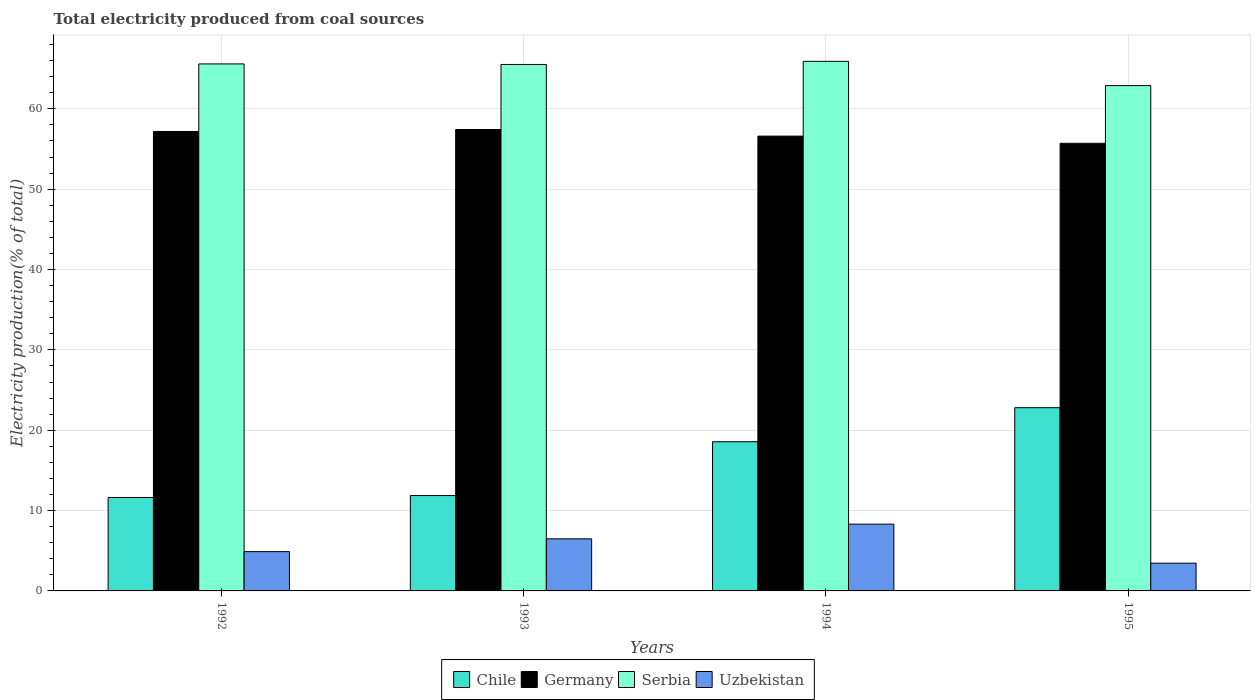How many different coloured bars are there?
Make the answer very short. 4. How many groups of bars are there?
Offer a terse response. 4. Are the number of bars per tick equal to the number of legend labels?
Make the answer very short. Yes. In how many cases, is the number of bars for a given year not equal to the number of legend labels?
Keep it short and to the point. 0. What is the total electricity produced in Serbia in 1995?
Provide a short and direct response. 62.89. Across all years, what is the maximum total electricity produced in Germany?
Ensure brevity in your answer.  57.43. Across all years, what is the minimum total electricity produced in Serbia?
Your answer should be compact. 62.89. In which year was the total electricity produced in Serbia maximum?
Your answer should be compact. 1994. What is the total total electricity produced in Chile in the graph?
Provide a succinct answer. 64.87. What is the difference between the total electricity produced in Chile in 1993 and that in 1995?
Your answer should be compact. -10.93. What is the difference between the total electricity produced in Germany in 1992 and the total electricity produced in Serbia in 1993?
Offer a terse response. -8.34. What is the average total electricity produced in Germany per year?
Your answer should be compact. 56.73. In the year 1992, what is the difference between the total electricity produced in Serbia and total electricity produced in Uzbekistan?
Provide a succinct answer. 60.7. In how many years, is the total electricity produced in Serbia greater than 34 %?
Ensure brevity in your answer.  4. What is the ratio of the total electricity produced in Germany in 1992 to that in 1995?
Ensure brevity in your answer.  1.03. Is the total electricity produced in Uzbekistan in 1994 less than that in 1995?
Make the answer very short. No. What is the difference between the highest and the second highest total electricity produced in Germany?
Provide a short and direct response. 0.24. What is the difference between the highest and the lowest total electricity produced in Serbia?
Make the answer very short. 3.02. In how many years, is the total electricity produced in Chile greater than the average total electricity produced in Chile taken over all years?
Give a very brief answer. 2. Is it the case that in every year, the sum of the total electricity produced in Uzbekistan and total electricity produced in Germany is greater than the sum of total electricity produced in Chile and total electricity produced in Serbia?
Offer a terse response. Yes. What does the 2nd bar from the left in 1994 represents?
Provide a short and direct response. Germany. Is it the case that in every year, the sum of the total electricity produced in Uzbekistan and total electricity produced in Germany is greater than the total electricity produced in Serbia?
Keep it short and to the point. No. How many bars are there?
Offer a terse response. 16. How many years are there in the graph?
Ensure brevity in your answer.  4. Does the graph contain any zero values?
Give a very brief answer. No. Where does the legend appear in the graph?
Ensure brevity in your answer.  Bottom center. What is the title of the graph?
Make the answer very short. Total electricity produced from coal sources. What is the label or title of the Y-axis?
Your answer should be compact. Electricity production(% of total). What is the Electricity production(% of total) of Chile in 1992?
Provide a short and direct response. 11.63. What is the Electricity production(% of total) of Germany in 1992?
Offer a terse response. 57.18. What is the Electricity production(% of total) of Serbia in 1992?
Provide a short and direct response. 65.59. What is the Electricity production(% of total) of Uzbekistan in 1992?
Your answer should be compact. 4.89. What is the Electricity production(% of total) in Chile in 1993?
Keep it short and to the point. 11.87. What is the Electricity production(% of total) in Germany in 1993?
Offer a terse response. 57.43. What is the Electricity production(% of total) in Serbia in 1993?
Offer a terse response. 65.52. What is the Electricity production(% of total) in Uzbekistan in 1993?
Make the answer very short. 6.48. What is the Electricity production(% of total) of Chile in 1994?
Offer a very short reply. 18.57. What is the Electricity production(% of total) of Germany in 1994?
Give a very brief answer. 56.6. What is the Electricity production(% of total) of Serbia in 1994?
Your response must be concise. 65.91. What is the Electricity production(% of total) in Uzbekistan in 1994?
Your response must be concise. 8.31. What is the Electricity production(% of total) in Chile in 1995?
Offer a terse response. 22.8. What is the Electricity production(% of total) in Germany in 1995?
Provide a succinct answer. 55.71. What is the Electricity production(% of total) of Serbia in 1995?
Your answer should be compact. 62.89. What is the Electricity production(% of total) of Uzbekistan in 1995?
Give a very brief answer. 3.45. Across all years, what is the maximum Electricity production(% of total) in Chile?
Offer a terse response. 22.8. Across all years, what is the maximum Electricity production(% of total) of Germany?
Offer a very short reply. 57.43. Across all years, what is the maximum Electricity production(% of total) in Serbia?
Make the answer very short. 65.91. Across all years, what is the maximum Electricity production(% of total) of Uzbekistan?
Give a very brief answer. 8.31. Across all years, what is the minimum Electricity production(% of total) of Chile?
Provide a succinct answer. 11.63. Across all years, what is the minimum Electricity production(% of total) of Germany?
Provide a succinct answer. 55.71. Across all years, what is the minimum Electricity production(% of total) in Serbia?
Your response must be concise. 62.89. Across all years, what is the minimum Electricity production(% of total) of Uzbekistan?
Make the answer very short. 3.45. What is the total Electricity production(% of total) in Chile in the graph?
Offer a very short reply. 64.87. What is the total Electricity production(% of total) in Germany in the graph?
Give a very brief answer. 226.92. What is the total Electricity production(% of total) in Serbia in the graph?
Ensure brevity in your answer.  259.9. What is the total Electricity production(% of total) in Uzbekistan in the graph?
Offer a terse response. 23.14. What is the difference between the Electricity production(% of total) in Chile in 1992 and that in 1993?
Your response must be concise. -0.24. What is the difference between the Electricity production(% of total) of Germany in 1992 and that in 1993?
Offer a very short reply. -0.24. What is the difference between the Electricity production(% of total) in Serbia in 1992 and that in 1993?
Provide a short and direct response. 0.07. What is the difference between the Electricity production(% of total) in Uzbekistan in 1992 and that in 1993?
Offer a terse response. -1.59. What is the difference between the Electricity production(% of total) of Chile in 1992 and that in 1994?
Your answer should be very brief. -6.94. What is the difference between the Electricity production(% of total) in Germany in 1992 and that in 1994?
Offer a very short reply. 0.58. What is the difference between the Electricity production(% of total) in Serbia in 1992 and that in 1994?
Keep it short and to the point. -0.32. What is the difference between the Electricity production(% of total) of Uzbekistan in 1992 and that in 1994?
Offer a very short reply. -3.42. What is the difference between the Electricity production(% of total) of Chile in 1992 and that in 1995?
Your answer should be compact. -11.17. What is the difference between the Electricity production(% of total) of Germany in 1992 and that in 1995?
Keep it short and to the point. 1.48. What is the difference between the Electricity production(% of total) in Serbia in 1992 and that in 1995?
Provide a succinct answer. 2.7. What is the difference between the Electricity production(% of total) in Uzbekistan in 1992 and that in 1995?
Give a very brief answer. 1.44. What is the difference between the Electricity production(% of total) in Chile in 1993 and that in 1994?
Provide a succinct answer. -6.7. What is the difference between the Electricity production(% of total) in Germany in 1993 and that in 1994?
Give a very brief answer. 0.82. What is the difference between the Electricity production(% of total) in Serbia in 1993 and that in 1994?
Offer a terse response. -0.39. What is the difference between the Electricity production(% of total) of Uzbekistan in 1993 and that in 1994?
Your response must be concise. -1.83. What is the difference between the Electricity production(% of total) of Chile in 1993 and that in 1995?
Your answer should be compact. -10.93. What is the difference between the Electricity production(% of total) in Germany in 1993 and that in 1995?
Offer a terse response. 1.72. What is the difference between the Electricity production(% of total) of Serbia in 1993 and that in 1995?
Offer a very short reply. 2.63. What is the difference between the Electricity production(% of total) of Uzbekistan in 1993 and that in 1995?
Your answer should be very brief. 3.03. What is the difference between the Electricity production(% of total) in Chile in 1994 and that in 1995?
Make the answer very short. -4.24. What is the difference between the Electricity production(% of total) in Germany in 1994 and that in 1995?
Offer a terse response. 0.9. What is the difference between the Electricity production(% of total) in Serbia in 1994 and that in 1995?
Provide a short and direct response. 3.02. What is the difference between the Electricity production(% of total) in Uzbekistan in 1994 and that in 1995?
Your answer should be very brief. 4.86. What is the difference between the Electricity production(% of total) of Chile in 1992 and the Electricity production(% of total) of Germany in 1993?
Make the answer very short. -45.8. What is the difference between the Electricity production(% of total) of Chile in 1992 and the Electricity production(% of total) of Serbia in 1993?
Your answer should be very brief. -53.89. What is the difference between the Electricity production(% of total) of Chile in 1992 and the Electricity production(% of total) of Uzbekistan in 1993?
Your answer should be compact. 5.15. What is the difference between the Electricity production(% of total) of Germany in 1992 and the Electricity production(% of total) of Serbia in 1993?
Offer a very short reply. -8.34. What is the difference between the Electricity production(% of total) in Germany in 1992 and the Electricity production(% of total) in Uzbekistan in 1993?
Your response must be concise. 50.7. What is the difference between the Electricity production(% of total) in Serbia in 1992 and the Electricity production(% of total) in Uzbekistan in 1993?
Offer a terse response. 59.11. What is the difference between the Electricity production(% of total) of Chile in 1992 and the Electricity production(% of total) of Germany in 1994?
Give a very brief answer. -44.97. What is the difference between the Electricity production(% of total) in Chile in 1992 and the Electricity production(% of total) in Serbia in 1994?
Offer a terse response. -54.28. What is the difference between the Electricity production(% of total) in Chile in 1992 and the Electricity production(% of total) in Uzbekistan in 1994?
Give a very brief answer. 3.32. What is the difference between the Electricity production(% of total) in Germany in 1992 and the Electricity production(% of total) in Serbia in 1994?
Offer a terse response. -8.72. What is the difference between the Electricity production(% of total) in Germany in 1992 and the Electricity production(% of total) in Uzbekistan in 1994?
Your answer should be very brief. 48.87. What is the difference between the Electricity production(% of total) in Serbia in 1992 and the Electricity production(% of total) in Uzbekistan in 1994?
Keep it short and to the point. 57.28. What is the difference between the Electricity production(% of total) of Chile in 1992 and the Electricity production(% of total) of Germany in 1995?
Give a very brief answer. -44.08. What is the difference between the Electricity production(% of total) in Chile in 1992 and the Electricity production(% of total) in Serbia in 1995?
Offer a terse response. -51.26. What is the difference between the Electricity production(% of total) in Chile in 1992 and the Electricity production(% of total) in Uzbekistan in 1995?
Offer a very short reply. 8.18. What is the difference between the Electricity production(% of total) of Germany in 1992 and the Electricity production(% of total) of Serbia in 1995?
Your answer should be compact. -5.7. What is the difference between the Electricity production(% of total) of Germany in 1992 and the Electricity production(% of total) of Uzbekistan in 1995?
Your response must be concise. 53.73. What is the difference between the Electricity production(% of total) in Serbia in 1992 and the Electricity production(% of total) in Uzbekistan in 1995?
Your answer should be very brief. 62.13. What is the difference between the Electricity production(% of total) of Chile in 1993 and the Electricity production(% of total) of Germany in 1994?
Your answer should be compact. -44.73. What is the difference between the Electricity production(% of total) of Chile in 1993 and the Electricity production(% of total) of Serbia in 1994?
Provide a succinct answer. -54.04. What is the difference between the Electricity production(% of total) of Chile in 1993 and the Electricity production(% of total) of Uzbekistan in 1994?
Offer a terse response. 3.56. What is the difference between the Electricity production(% of total) of Germany in 1993 and the Electricity production(% of total) of Serbia in 1994?
Keep it short and to the point. -8.48. What is the difference between the Electricity production(% of total) of Germany in 1993 and the Electricity production(% of total) of Uzbekistan in 1994?
Make the answer very short. 49.12. What is the difference between the Electricity production(% of total) of Serbia in 1993 and the Electricity production(% of total) of Uzbekistan in 1994?
Make the answer very short. 57.21. What is the difference between the Electricity production(% of total) in Chile in 1993 and the Electricity production(% of total) in Germany in 1995?
Make the answer very short. -43.84. What is the difference between the Electricity production(% of total) of Chile in 1993 and the Electricity production(% of total) of Serbia in 1995?
Make the answer very short. -51.02. What is the difference between the Electricity production(% of total) of Chile in 1993 and the Electricity production(% of total) of Uzbekistan in 1995?
Give a very brief answer. 8.42. What is the difference between the Electricity production(% of total) in Germany in 1993 and the Electricity production(% of total) in Serbia in 1995?
Your response must be concise. -5.46. What is the difference between the Electricity production(% of total) in Germany in 1993 and the Electricity production(% of total) in Uzbekistan in 1995?
Keep it short and to the point. 53.97. What is the difference between the Electricity production(% of total) of Serbia in 1993 and the Electricity production(% of total) of Uzbekistan in 1995?
Give a very brief answer. 62.07. What is the difference between the Electricity production(% of total) in Chile in 1994 and the Electricity production(% of total) in Germany in 1995?
Make the answer very short. -37.14. What is the difference between the Electricity production(% of total) in Chile in 1994 and the Electricity production(% of total) in Serbia in 1995?
Provide a short and direct response. -44.32. What is the difference between the Electricity production(% of total) in Chile in 1994 and the Electricity production(% of total) in Uzbekistan in 1995?
Offer a terse response. 15.11. What is the difference between the Electricity production(% of total) of Germany in 1994 and the Electricity production(% of total) of Serbia in 1995?
Keep it short and to the point. -6.28. What is the difference between the Electricity production(% of total) in Germany in 1994 and the Electricity production(% of total) in Uzbekistan in 1995?
Ensure brevity in your answer.  53.15. What is the difference between the Electricity production(% of total) in Serbia in 1994 and the Electricity production(% of total) in Uzbekistan in 1995?
Keep it short and to the point. 62.45. What is the average Electricity production(% of total) of Chile per year?
Make the answer very short. 16.22. What is the average Electricity production(% of total) in Germany per year?
Provide a short and direct response. 56.73. What is the average Electricity production(% of total) of Serbia per year?
Make the answer very short. 64.98. What is the average Electricity production(% of total) of Uzbekistan per year?
Offer a terse response. 5.78. In the year 1992, what is the difference between the Electricity production(% of total) in Chile and Electricity production(% of total) in Germany?
Ensure brevity in your answer.  -45.55. In the year 1992, what is the difference between the Electricity production(% of total) in Chile and Electricity production(% of total) in Serbia?
Ensure brevity in your answer.  -53.96. In the year 1992, what is the difference between the Electricity production(% of total) in Chile and Electricity production(% of total) in Uzbekistan?
Ensure brevity in your answer.  6.74. In the year 1992, what is the difference between the Electricity production(% of total) in Germany and Electricity production(% of total) in Serbia?
Your answer should be compact. -8.41. In the year 1992, what is the difference between the Electricity production(% of total) of Germany and Electricity production(% of total) of Uzbekistan?
Provide a succinct answer. 52.29. In the year 1992, what is the difference between the Electricity production(% of total) of Serbia and Electricity production(% of total) of Uzbekistan?
Provide a succinct answer. 60.7. In the year 1993, what is the difference between the Electricity production(% of total) in Chile and Electricity production(% of total) in Germany?
Provide a short and direct response. -45.56. In the year 1993, what is the difference between the Electricity production(% of total) in Chile and Electricity production(% of total) in Serbia?
Ensure brevity in your answer.  -53.65. In the year 1993, what is the difference between the Electricity production(% of total) in Chile and Electricity production(% of total) in Uzbekistan?
Offer a terse response. 5.39. In the year 1993, what is the difference between the Electricity production(% of total) of Germany and Electricity production(% of total) of Serbia?
Make the answer very short. -8.1. In the year 1993, what is the difference between the Electricity production(% of total) of Germany and Electricity production(% of total) of Uzbekistan?
Your response must be concise. 50.94. In the year 1993, what is the difference between the Electricity production(% of total) in Serbia and Electricity production(% of total) in Uzbekistan?
Provide a short and direct response. 59.04. In the year 1994, what is the difference between the Electricity production(% of total) of Chile and Electricity production(% of total) of Germany?
Make the answer very short. -38.04. In the year 1994, what is the difference between the Electricity production(% of total) of Chile and Electricity production(% of total) of Serbia?
Your answer should be very brief. -47.34. In the year 1994, what is the difference between the Electricity production(% of total) in Chile and Electricity production(% of total) in Uzbekistan?
Provide a short and direct response. 10.26. In the year 1994, what is the difference between the Electricity production(% of total) of Germany and Electricity production(% of total) of Serbia?
Keep it short and to the point. -9.3. In the year 1994, what is the difference between the Electricity production(% of total) of Germany and Electricity production(% of total) of Uzbekistan?
Your response must be concise. 48.29. In the year 1994, what is the difference between the Electricity production(% of total) of Serbia and Electricity production(% of total) of Uzbekistan?
Keep it short and to the point. 57.6. In the year 1995, what is the difference between the Electricity production(% of total) in Chile and Electricity production(% of total) in Germany?
Give a very brief answer. -32.9. In the year 1995, what is the difference between the Electricity production(% of total) of Chile and Electricity production(% of total) of Serbia?
Keep it short and to the point. -40.08. In the year 1995, what is the difference between the Electricity production(% of total) in Chile and Electricity production(% of total) in Uzbekistan?
Keep it short and to the point. 19.35. In the year 1995, what is the difference between the Electricity production(% of total) of Germany and Electricity production(% of total) of Serbia?
Make the answer very short. -7.18. In the year 1995, what is the difference between the Electricity production(% of total) in Germany and Electricity production(% of total) in Uzbekistan?
Your answer should be very brief. 52.25. In the year 1995, what is the difference between the Electricity production(% of total) of Serbia and Electricity production(% of total) of Uzbekistan?
Ensure brevity in your answer.  59.43. What is the ratio of the Electricity production(% of total) of Chile in 1992 to that in 1993?
Offer a very short reply. 0.98. What is the ratio of the Electricity production(% of total) of Germany in 1992 to that in 1993?
Ensure brevity in your answer.  1. What is the ratio of the Electricity production(% of total) in Serbia in 1992 to that in 1993?
Your answer should be very brief. 1. What is the ratio of the Electricity production(% of total) of Uzbekistan in 1992 to that in 1993?
Your answer should be very brief. 0.75. What is the ratio of the Electricity production(% of total) in Chile in 1992 to that in 1994?
Your answer should be compact. 0.63. What is the ratio of the Electricity production(% of total) in Germany in 1992 to that in 1994?
Your answer should be very brief. 1.01. What is the ratio of the Electricity production(% of total) in Uzbekistan in 1992 to that in 1994?
Your response must be concise. 0.59. What is the ratio of the Electricity production(% of total) of Chile in 1992 to that in 1995?
Make the answer very short. 0.51. What is the ratio of the Electricity production(% of total) in Germany in 1992 to that in 1995?
Ensure brevity in your answer.  1.03. What is the ratio of the Electricity production(% of total) of Serbia in 1992 to that in 1995?
Provide a short and direct response. 1.04. What is the ratio of the Electricity production(% of total) in Uzbekistan in 1992 to that in 1995?
Provide a short and direct response. 1.42. What is the ratio of the Electricity production(% of total) of Chile in 1993 to that in 1994?
Offer a terse response. 0.64. What is the ratio of the Electricity production(% of total) of Germany in 1993 to that in 1994?
Provide a succinct answer. 1.01. What is the ratio of the Electricity production(% of total) in Uzbekistan in 1993 to that in 1994?
Make the answer very short. 0.78. What is the ratio of the Electricity production(% of total) of Chile in 1993 to that in 1995?
Provide a short and direct response. 0.52. What is the ratio of the Electricity production(% of total) in Germany in 1993 to that in 1995?
Your answer should be very brief. 1.03. What is the ratio of the Electricity production(% of total) of Serbia in 1993 to that in 1995?
Offer a terse response. 1.04. What is the ratio of the Electricity production(% of total) of Uzbekistan in 1993 to that in 1995?
Provide a succinct answer. 1.88. What is the ratio of the Electricity production(% of total) of Chile in 1994 to that in 1995?
Make the answer very short. 0.81. What is the ratio of the Electricity production(% of total) of Germany in 1994 to that in 1995?
Your answer should be compact. 1.02. What is the ratio of the Electricity production(% of total) in Serbia in 1994 to that in 1995?
Your answer should be very brief. 1.05. What is the ratio of the Electricity production(% of total) of Uzbekistan in 1994 to that in 1995?
Provide a short and direct response. 2.41. What is the difference between the highest and the second highest Electricity production(% of total) in Chile?
Offer a very short reply. 4.24. What is the difference between the highest and the second highest Electricity production(% of total) in Germany?
Your answer should be very brief. 0.24. What is the difference between the highest and the second highest Electricity production(% of total) of Serbia?
Your answer should be compact. 0.32. What is the difference between the highest and the second highest Electricity production(% of total) of Uzbekistan?
Provide a short and direct response. 1.83. What is the difference between the highest and the lowest Electricity production(% of total) in Chile?
Provide a succinct answer. 11.17. What is the difference between the highest and the lowest Electricity production(% of total) of Germany?
Your response must be concise. 1.72. What is the difference between the highest and the lowest Electricity production(% of total) in Serbia?
Provide a short and direct response. 3.02. What is the difference between the highest and the lowest Electricity production(% of total) of Uzbekistan?
Give a very brief answer. 4.86. 